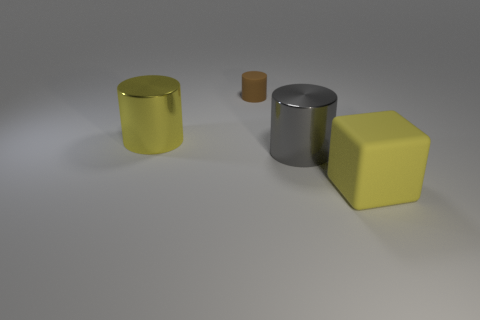Is there anything else that is the same size as the brown object?
Keep it short and to the point. No. There is a yellow object to the right of the big cylinder to the left of the brown rubber thing; is there a brown rubber cylinder that is left of it?
Your response must be concise. Yes. How big is the gray metallic object?
Provide a succinct answer. Large. What is the size of the matte object to the left of the big yellow block?
Your answer should be very brief. Small. There is a matte object that is behind the yellow cylinder; is it the same size as the big matte object?
Provide a short and direct response. No. Are there any other things of the same color as the large rubber thing?
Offer a terse response. Yes. What is the shape of the small thing?
Offer a terse response. Cylinder. What number of yellow things are in front of the large gray metal object and to the left of the cube?
Make the answer very short. 0. There is a small object that is the same shape as the big yellow metallic object; what is its material?
Your answer should be very brief. Rubber. Are there the same number of small rubber cylinders that are in front of the gray metal cylinder and metallic cylinders right of the tiny cylinder?
Provide a succinct answer. No. 